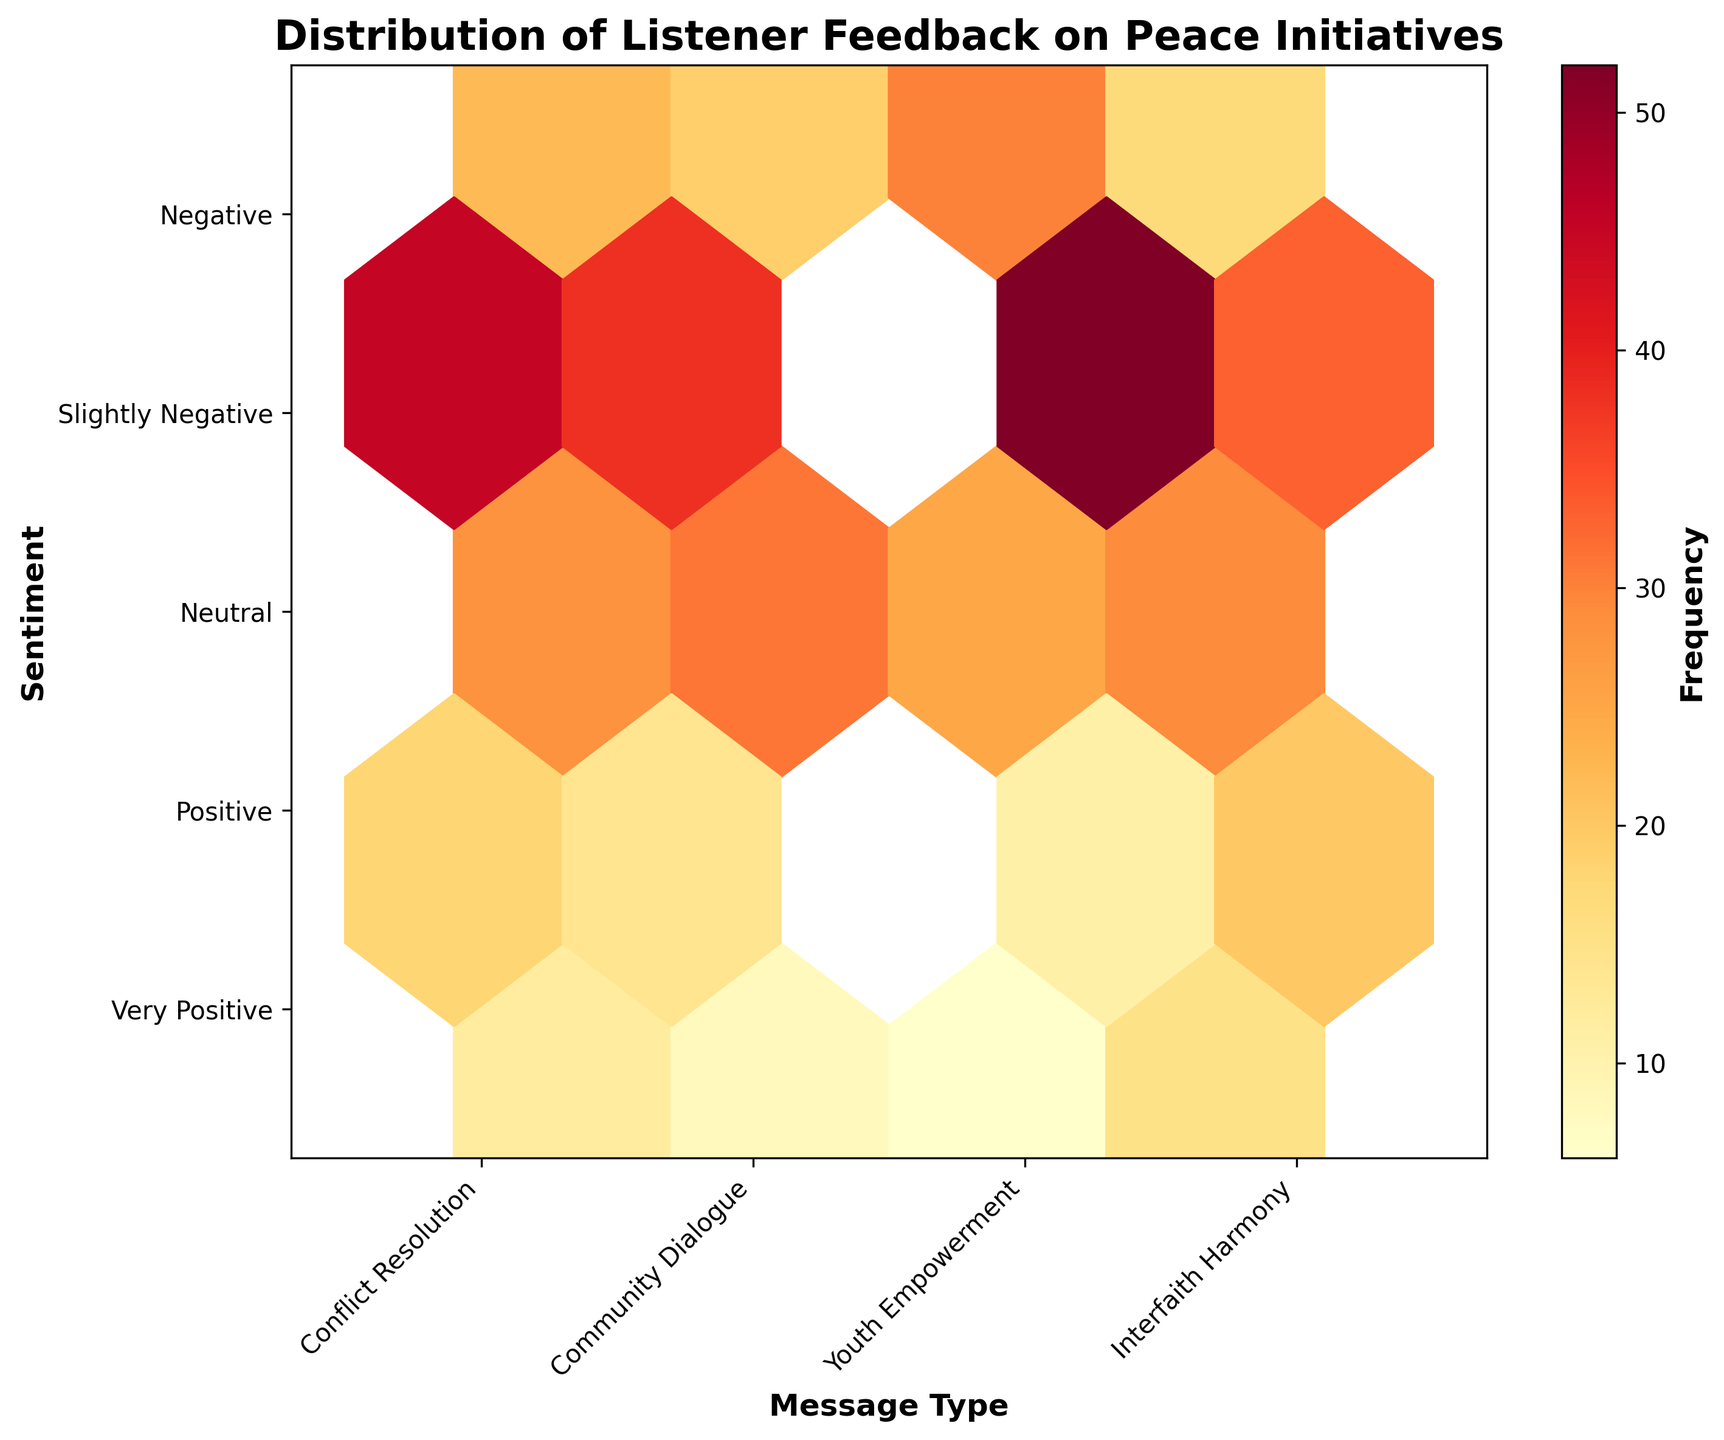What is the title of the plot? The title is displayed at the top of the plot and is usually larger and bolder to indicate its importance.
Answer: Distribution of Listener Feedback on Peace Initiatives How many sentiment categories are used in the plot? The y-axis labels correspond to different sentiment categories. Count the labels from the y-axis.
Answer: 5 Which message type has the highest number of 'Very Positive' feedbacks? Look at the hexbin plot and identify the x-axis tick that corresponds to the highest intensity in the 'Very Positive' y-coordinate.
Answer: Youth Empowerment How many feedbacks are recorded as 'Negative' for 'Community Dialogue'? Find the intersection of 'Community Dialogue' on the x-axis and 'Negative' on the y-axis and read the frequency from the color intensity or color bar.
Answer: 8 What sentiment has the highest feedback frequency for 'Interfaith Harmony'? Check the 'Interfaith Harmony' section across the sentiments and identify the bin with the highest intensity.
Answer: Slightly Negative Compare the 'Positive' feedbacks between 'Conflict Resolution' and 'Youth Empowerment'. Which one is higher? Compare the color intensities at the 'Positive' sentiment for both 'Conflict Resolution' and 'Youth Empowerment'.
Answer: Youth Empowerment Which sentiment has the lowest feedback frequency for 'Youth Empowerment'? Check the 'Youth Empowerment' column across the sentiments and identify the bin with the lowest intensity.
Answer: Negative What is the total number of 'Slightly Negative' feedbacks across all message types? Summing up the frequencies for 'Slightly Negative' across all message types: Conflict Resolution (18) + Community Dialogue (14) + Youth Empowerment (11) + Interfaith Harmony (20) = 63
Answer: 63 How does 'Community Dialogue' compare to 'Conflict Resolution' in terms of 'Very Positive' feedback frequency? Compare the frequencies of 'Very Positive' feedbacks for both 'Community Dialogue' (19) and 'Conflict Resolution' (22) to determine which one is higher.
Answer: Conflict Resolution Which message type has the highest overall feedback frequency, regardless of sentiment category? Sum the frequencies for each message type and compare: Conflict Resolution (45+28+12+22+18=125), Community Dialogue (38+31+8+19+14=110), Youth Empowerment (52+25+6+30+11=124), Interfaith Harmony (33+29+15+17+20=114). 'Conflict Resolution' has the highest total with 125.
Answer: Conflict Resolution 